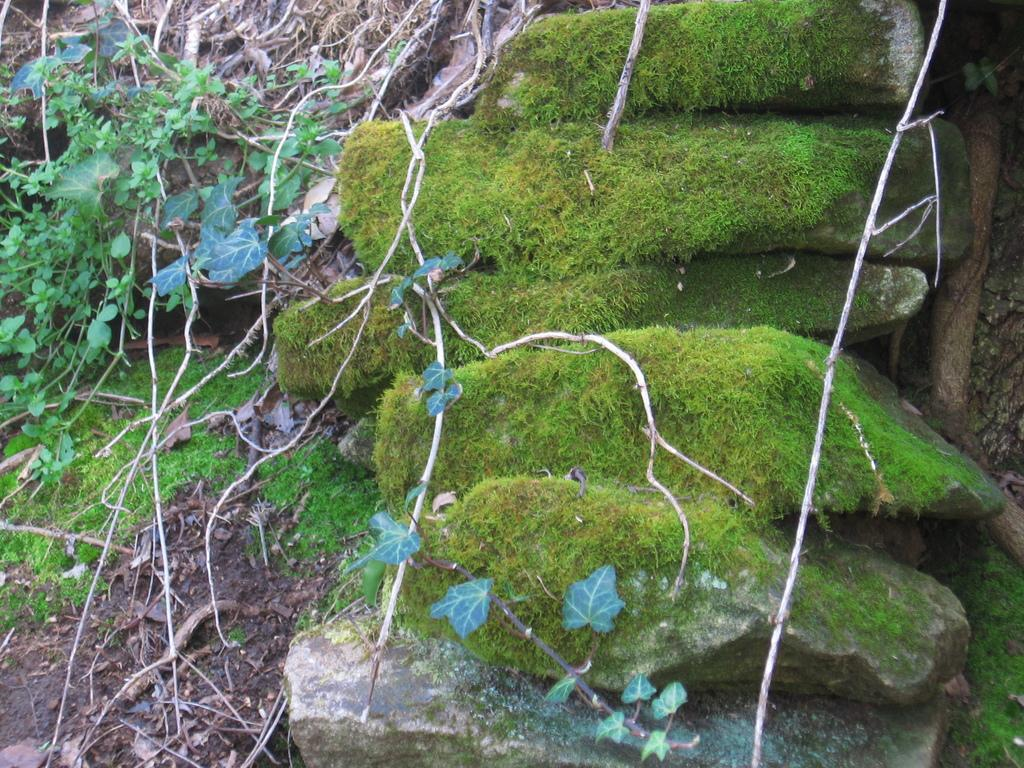What type of vegetation can be seen on the stones in the image? There is plant moss on some stones in the image. What other type of vegetation is visible in the image? There is grass visible in the image. What else can be seen in the image besides vegetation? There are plants, leaves, and dried branches visible in the image. What type of bread can be seen in the image? There is no bread present in the image. Can you describe the tail of the animal in the image? There is no animal with a tail present in the image. 